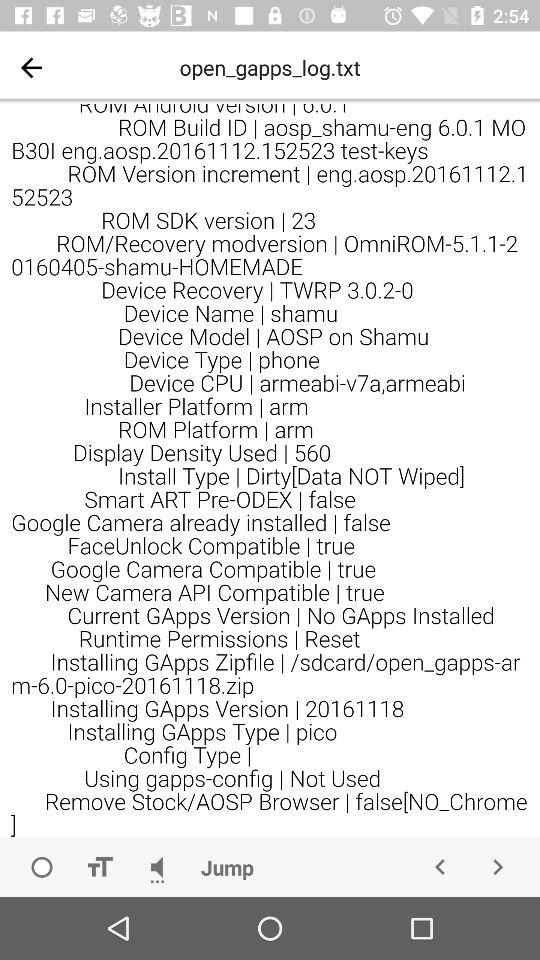Which GApps version is installed, pico or nano?
Answer the question using a single word or phrase. Pico 